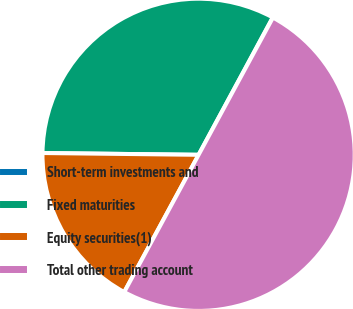Convert chart to OTSL. <chart><loc_0><loc_0><loc_500><loc_500><pie_chart><fcel>Short-term investments and<fcel>Fixed maturities<fcel>Equity securities(1)<fcel>Total other trading account<nl><fcel>0.03%<fcel>32.69%<fcel>17.28%<fcel>50.0%<nl></chart> 